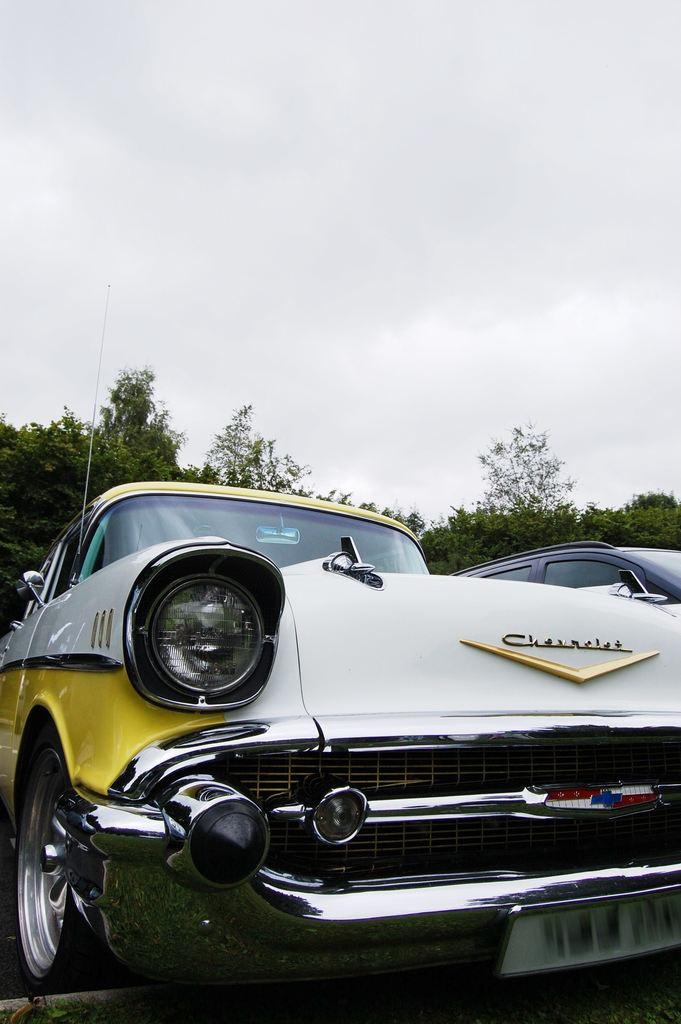What type of vehicles can be seen in the image? There are cars in the image. What other objects or features are present in the image? There are trees in the image. What can be seen in the background of the image? The sky is visible in the background of the image. What type of spark can be seen coming from the trees in the image? There is no spark present in the image; the trees are not emitting any sparks. 